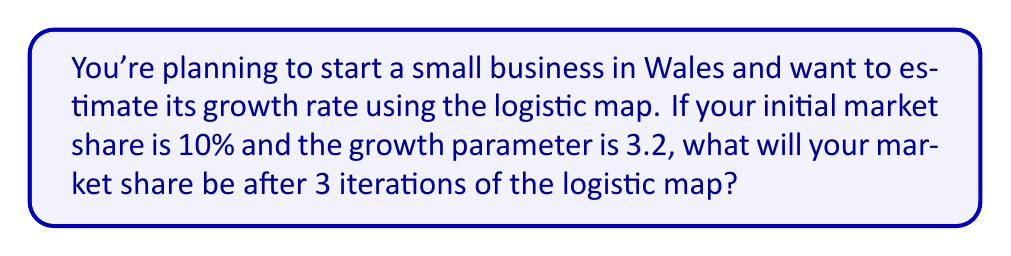Can you answer this question? Let's approach this step-by-step using the logistic map equation:

$$x_{n+1} = rx_n(1-x_n)$$

Where:
$x_n$ is the market share at iteration n
$r$ is the growth parameter

Given:
Initial market share $x_0 = 0.1$ (10%)
Growth parameter $r = 3.2$

Step 1: First iteration
$$x_1 = 3.2 * 0.1 * (1-0.1) = 0.288$$

Step 2: Second iteration
$$x_2 = 3.2 * 0.288 * (1-0.288) = 0.656$$

Step 3: Third iteration
$$x_3 = 3.2 * 0.656 * (1-0.656) = 0.722$$

Therefore, after 3 iterations, the market share will be approximately 0.722 or 72.2%.
Answer: 72.2% 